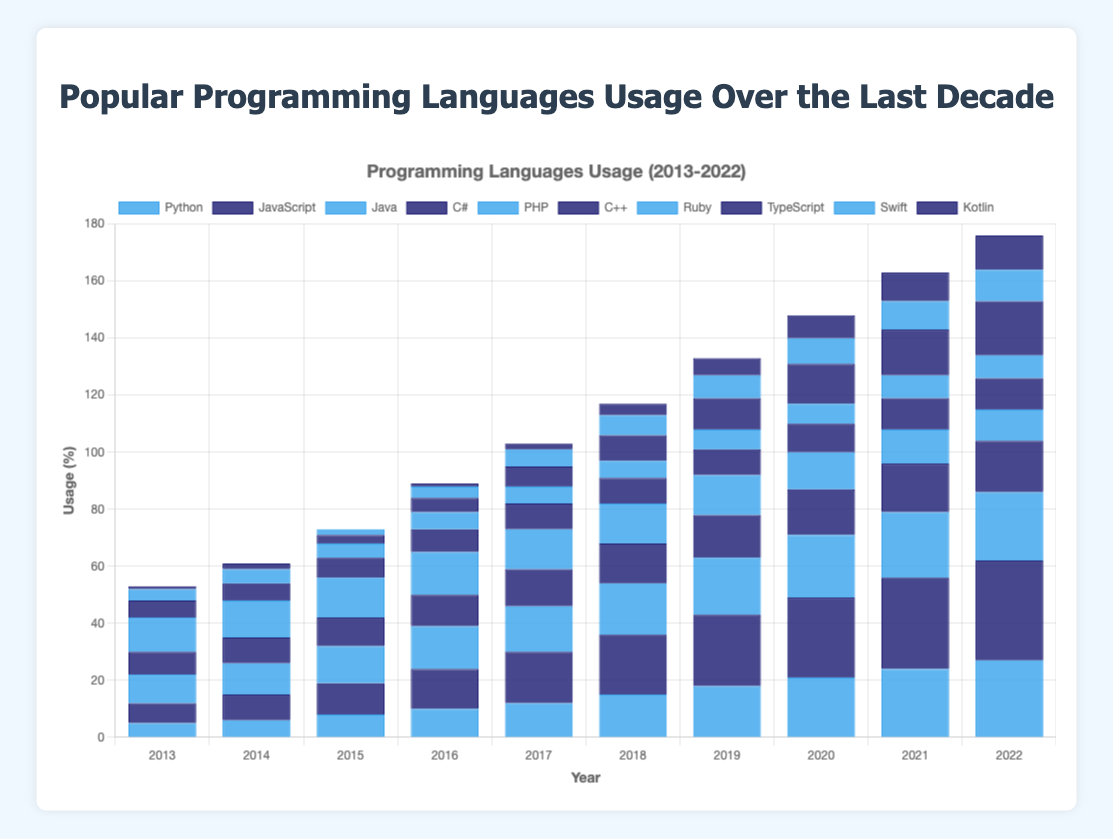What language saw the highest increase in usage from 2013 to 2022? Python saw the highest increase in usage from 2013 (5%) to 2022 (27%). The increase is calculated as 27% - 5% = 22%.
Answer: Python Between 2016 and 2020, which language's usage grew the most, and by how much? JavaScript's usage grew the most between 2016 (14%) and 2020 (28%). The increase is calculated as 28% - 14% = 14%.
Answer: JavaScript, 14% Looking at the bar colors, which languages consistently use the dark blue color? The languages consistently using dark blue are JavaScript, C#, PHP, and Ruby.
Answer: JavaScript, C#, PHP, Ruby During the decade, which language experienced a decrease in usage? PHP experienced a decrease in usage from 2013 (12%) to 2022 (11%), with a peak in between.
Answer: PHP Comparing the data for 2022, are there more languages with usage greater than 20% or less than 10%? In 2022, there are two languages with usage greater than 20% (JavaScript and Python) and four languages with usage less than 10% (C++, Ruby, Swift, Kotlin).
Answer: Less than 10% What was the average usage increase per year for TypeScript from 2013 to 2022? TypeScript usage increased from 1% in 2013 to 19% in 2022 over 9 years. The average increase per year is (19% - 1%) / 9 ≈ 2%.
Answer: 2% Which language had the smallest change in usage over the decade? Ruby had the smallest change in usage, increasing from 4% in 2013 to 8% in 2022. The total change is 4%.
Answer: Ruby Which language surpassed the 10% usage mark first, Python or Swift? Python surpassed the 10% usage mark first, reaching 10% in 2016, while Swift reached 11% in 2022.
Answer: Python How many languages had a usage increase of more than 10% over the decade? Six languages had a usage increase of more than 10%: Python, JavaScript, Java, C#, TypeScript, Kotlin.
Answer: 6 Considering the visual attributes, which year's bars are the tallest overall? The bars for the year 2022 are the tallest overall, indicating the highest combined usage for the programming languages shown.
Answer: 2022 